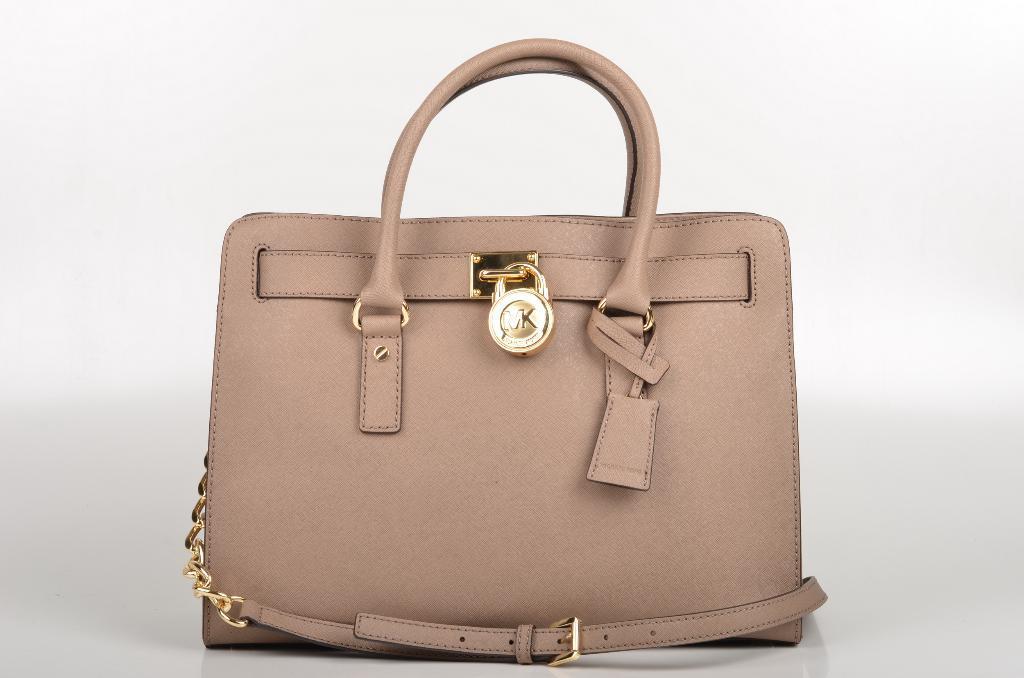Can you describe this image briefly? It's a beautiful handbag. 